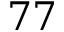<formula> <loc_0><loc_0><loc_500><loc_500>7 7</formula> 